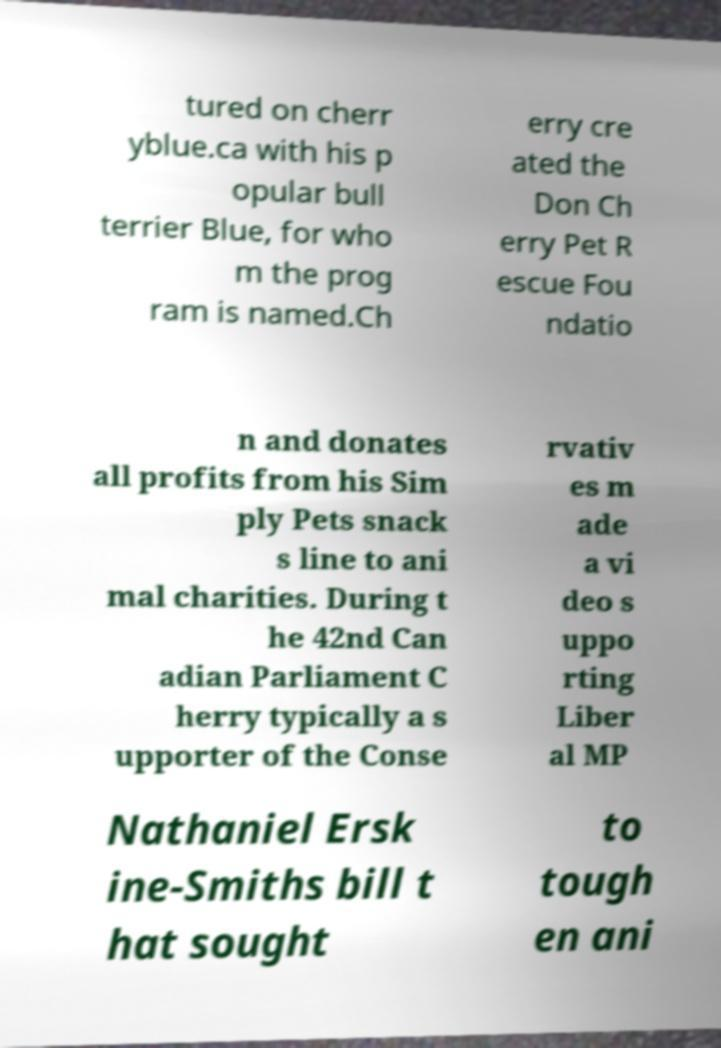What messages or text are displayed in this image? I need them in a readable, typed format. tured on cherr yblue.ca with his p opular bull terrier Blue, for who m the prog ram is named.Ch erry cre ated the Don Ch erry Pet R escue Fou ndatio n and donates all profits from his Sim ply Pets snack s line to ani mal charities. During t he 42nd Can adian Parliament C herry typically a s upporter of the Conse rvativ es m ade a vi deo s uppo rting Liber al MP Nathaniel Ersk ine-Smiths bill t hat sought to tough en ani 